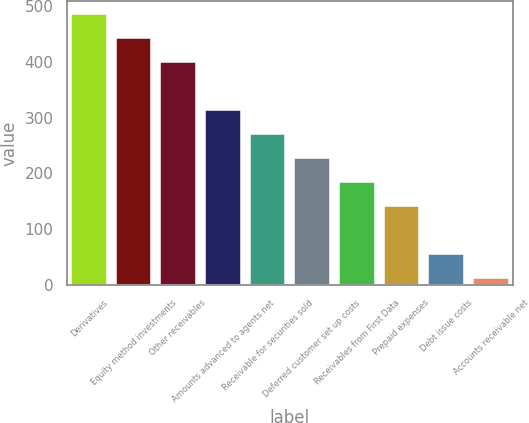Convert chart to OTSL. <chart><loc_0><loc_0><loc_500><loc_500><bar_chart><fcel>Derivatives<fcel>Equity method investments<fcel>Other receivables<fcel>Amounts advanced to agents net<fcel>Receivable for securities sold<fcel>Deferred customer set up costs<fcel>Receivables from First Data<fcel>Prepaid expenses<fcel>Debt issue costs<fcel>Accounts receivable net<nl><fcel>485.21<fcel>442.2<fcel>399.19<fcel>313.17<fcel>270.16<fcel>227.15<fcel>184.14<fcel>141.13<fcel>55.11<fcel>12.1<nl></chart> 